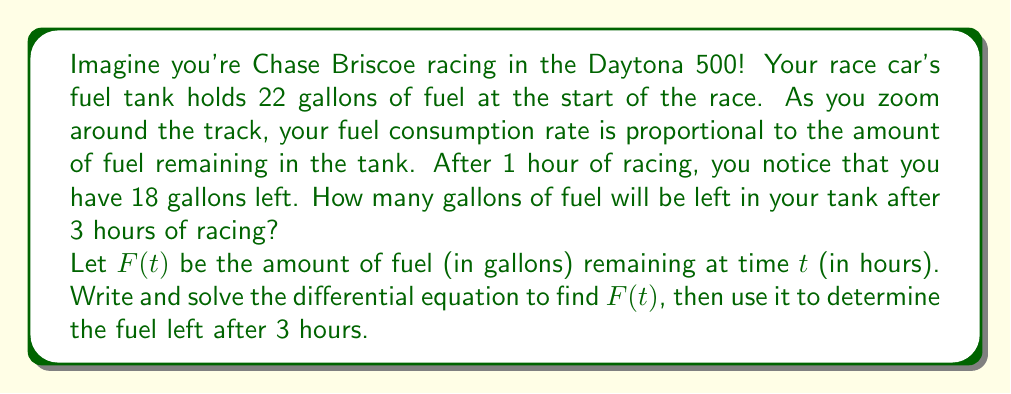What is the answer to this math problem? Let's approach this step-by-step:

1) The rate of fuel consumption is proportional to the amount of fuel remaining. This can be expressed as:

   $$\frac{dF}{dt} = -kF$$

   where $k$ is a positive constant and the negative sign indicates that fuel is decreasing.

2) We know that:
   $F(0) = 22$ (initial fuel)
   $F(1) = 18$ (fuel after 1 hour)

3) The general solution to this differential equation is:

   $$F(t) = Ce^{-kt}$$

   where $C$ is a constant we need to determine.

4) Using the initial condition:
   
   $F(0) = Ce^{-k(0)} = C = 22$

5) So our solution is:

   $$F(t) = 22e^{-kt}$$

6) Now we can use the condition at $t=1$ to find $k$:

   $18 = 22e^{-k(1)}$
   $\frac{18}{22} = e^{-k}$
   $\ln(\frac{18}{22}) = -k$
   $k = -\ln(\frac{18}{22}) \approx 0.2007$

7) Our final solution is:

   $$F(t) = 22e^{-0.2007t}$$

8) To find the fuel remaining after 3 hours, we calculate $F(3)$:

   $$F(3) = 22e^{-0.2007(3)} \approx 12.15$$

Therefore, after 3 hours of racing, there will be approximately 12.15 gallons of fuel left in the tank.
Answer: After 3 hours of racing, approximately 12.15 gallons of fuel will remain in the tank. 